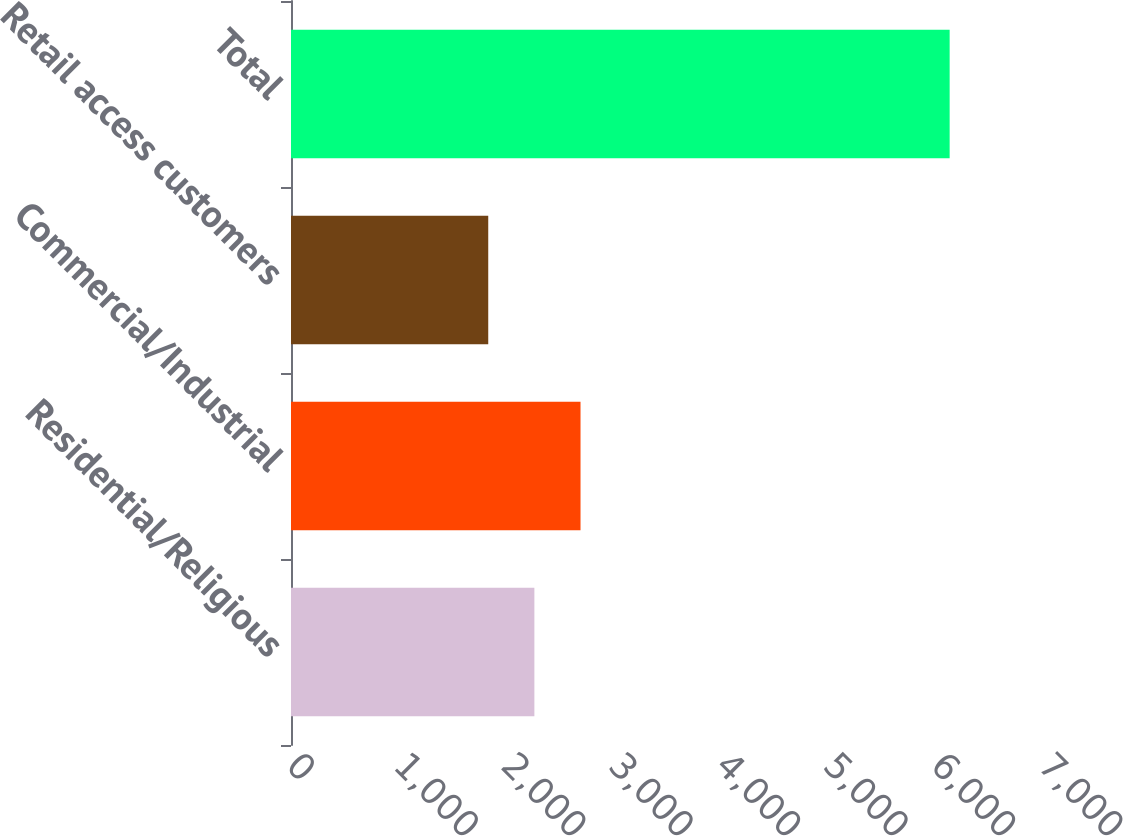<chart> <loc_0><loc_0><loc_500><loc_500><bar_chart><fcel>Residential/Religious<fcel>Commercial/Industrial<fcel>Retail access customers<fcel>Total<nl><fcel>2265.5<fcel>2695<fcel>1836<fcel>6131<nl></chart> 